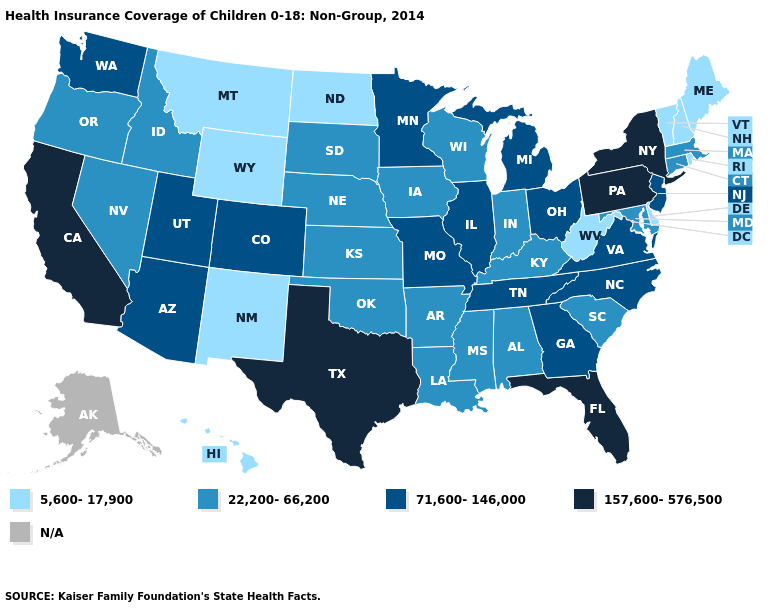Does Montana have the highest value in the West?
Concise answer only. No. Name the states that have a value in the range 22,200-66,200?
Short answer required. Alabama, Arkansas, Connecticut, Idaho, Indiana, Iowa, Kansas, Kentucky, Louisiana, Maryland, Massachusetts, Mississippi, Nebraska, Nevada, Oklahoma, Oregon, South Carolina, South Dakota, Wisconsin. Name the states that have a value in the range N/A?
Give a very brief answer. Alaska. Name the states that have a value in the range 157,600-576,500?
Be succinct. California, Florida, New York, Pennsylvania, Texas. What is the highest value in the MidWest ?
Answer briefly. 71,600-146,000. Name the states that have a value in the range N/A?
Quick response, please. Alaska. Does Colorado have the highest value in the USA?
Concise answer only. No. Is the legend a continuous bar?
Answer briefly. No. Does Arizona have the highest value in the West?
Answer briefly. No. What is the highest value in the MidWest ?
Write a very short answer. 71,600-146,000. What is the highest value in states that border North Carolina?
Write a very short answer. 71,600-146,000. Which states hav the highest value in the Northeast?
Concise answer only. New York, Pennsylvania. What is the value of Wisconsin?
Short answer required. 22,200-66,200. What is the value of California?
Quick response, please. 157,600-576,500. 